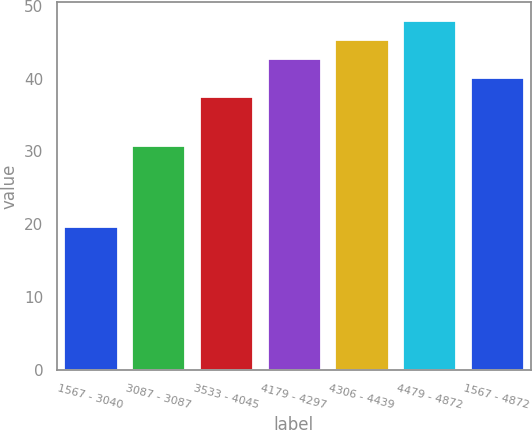<chart> <loc_0><loc_0><loc_500><loc_500><bar_chart><fcel>1567 - 3040<fcel>3087 - 3087<fcel>3533 - 4045<fcel>4179 - 4297<fcel>4306 - 4439<fcel>4479 - 4872<fcel>1567 - 4872<nl><fcel>19.76<fcel>30.87<fcel>37.63<fcel>42.85<fcel>45.46<fcel>48.07<fcel>40.24<nl></chart> 